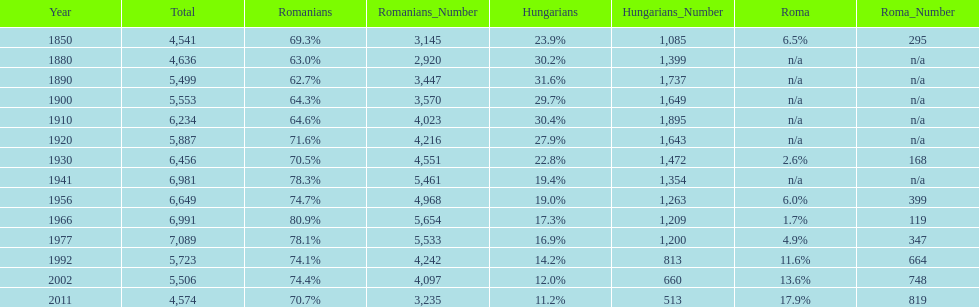In what year was there the largest percentage of hungarians? 1890. 